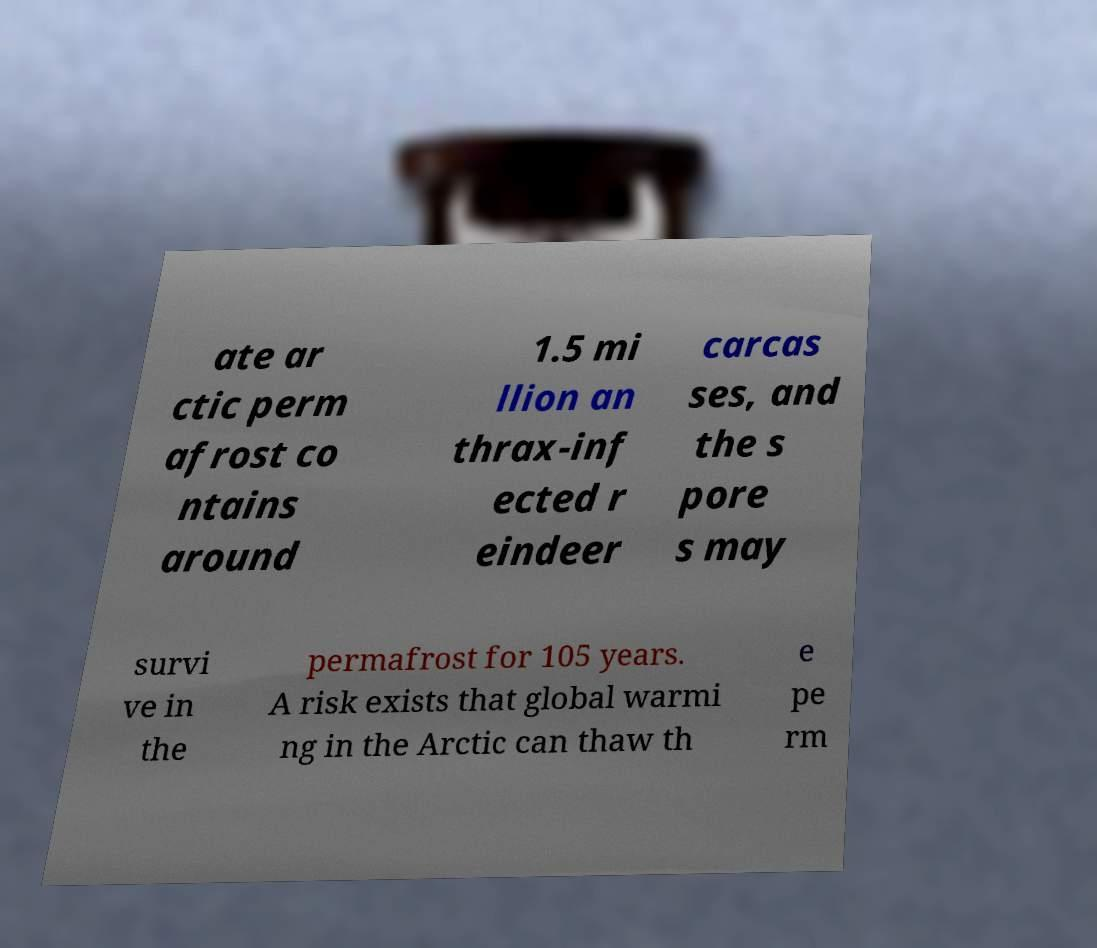Can you read and provide the text displayed in the image?This photo seems to have some interesting text. Can you extract and type it out for me? ate ar ctic perm afrost co ntains around 1.5 mi llion an thrax-inf ected r eindeer carcas ses, and the s pore s may survi ve in the permafrost for 105 years. A risk exists that global warmi ng in the Arctic can thaw th e pe rm 